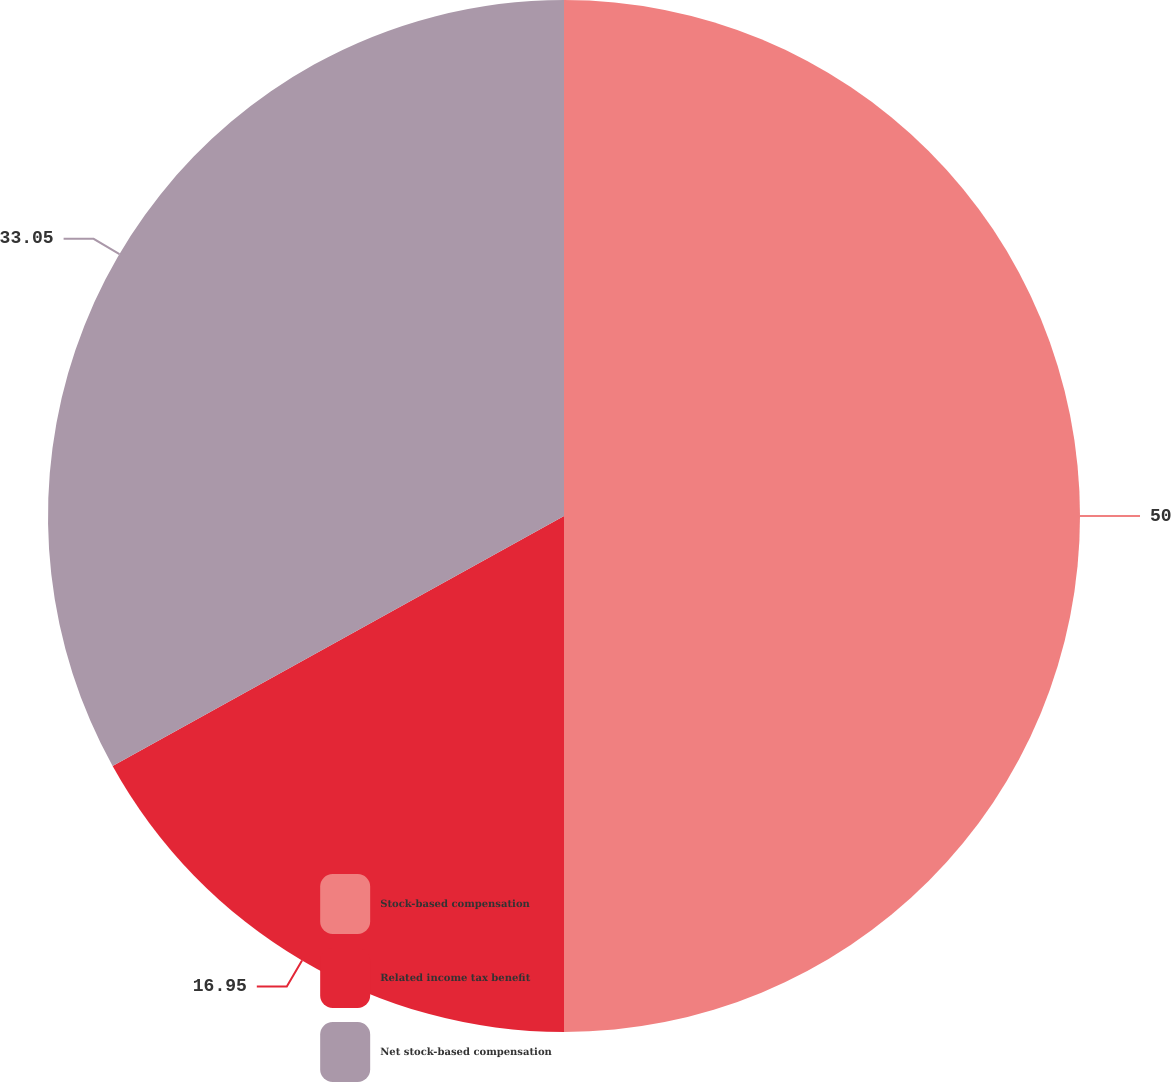Convert chart to OTSL. <chart><loc_0><loc_0><loc_500><loc_500><pie_chart><fcel>Stock-based compensation<fcel>Related income tax benefit<fcel>Net stock-based compensation<nl><fcel>50.0%<fcel>16.95%<fcel>33.05%<nl></chart> 